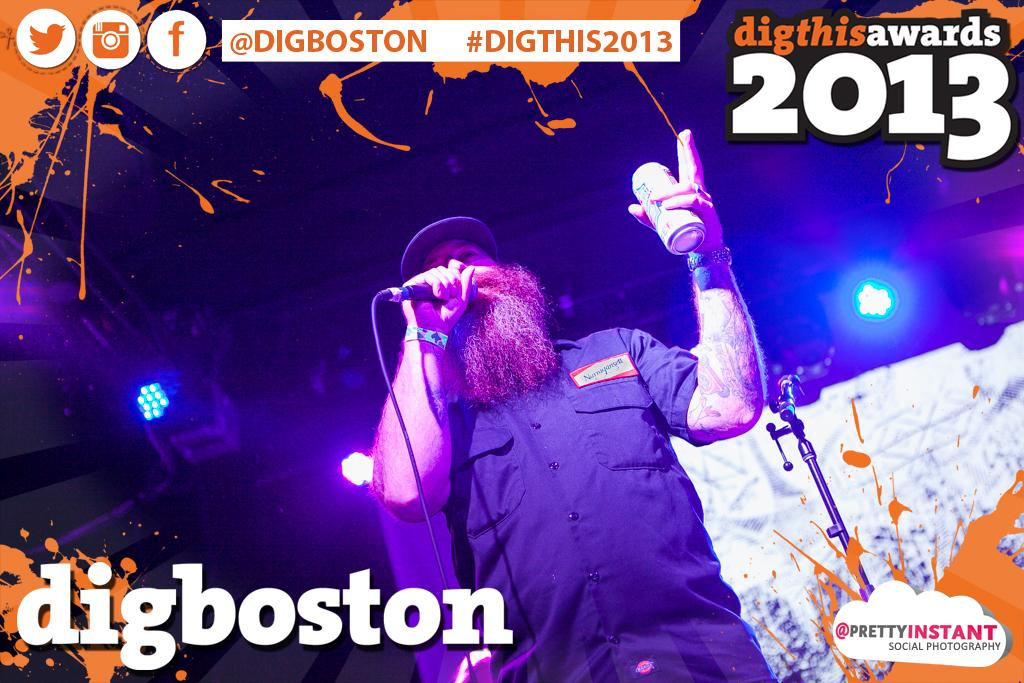<image>
Summarize the visual content of the image. A poster says digboston and shows a man with a microphone. 